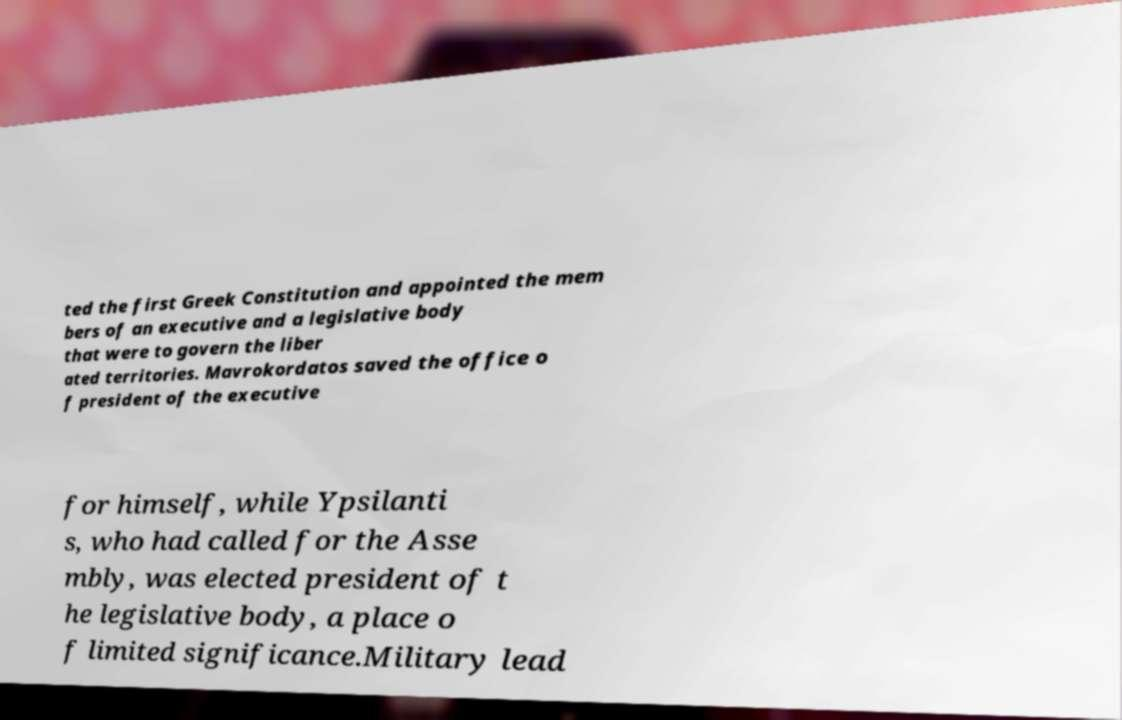Can you read and provide the text displayed in the image?This photo seems to have some interesting text. Can you extract and type it out for me? ted the first Greek Constitution and appointed the mem bers of an executive and a legislative body that were to govern the liber ated territories. Mavrokordatos saved the office o f president of the executive for himself, while Ypsilanti s, who had called for the Asse mbly, was elected president of t he legislative body, a place o f limited significance.Military lead 